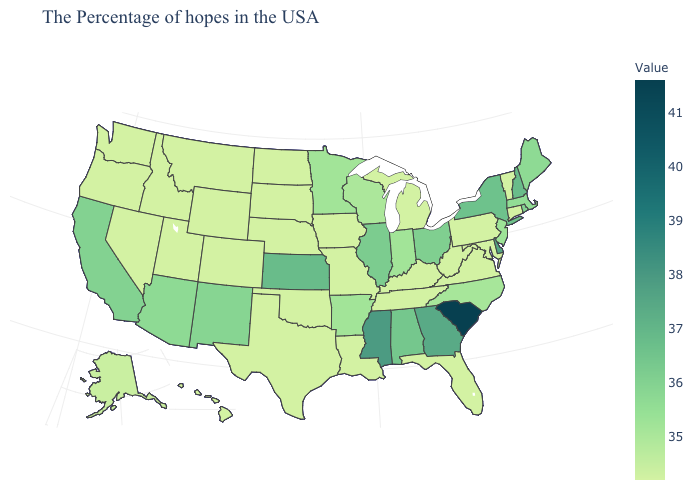Does New Hampshire have the highest value in the Northeast?
Quick response, please. Yes. Which states have the highest value in the USA?
Be succinct. South Carolina. Does Indiana have a higher value than Delaware?
Concise answer only. No. Among the states that border Arizona , which have the highest value?
Give a very brief answer. California. Among the states that border Kansas , which have the highest value?
Concise answer only. Missouri, Nebraska, Oklahoma, Colorado. Which states hav the highest value in the West?
Quick response, please. California. Among the states that border Louisiana , does Arkansas have the lowest value?
Short answer required. No. Which states hav the highest value in the South?
Be succinct. South Carolina. 